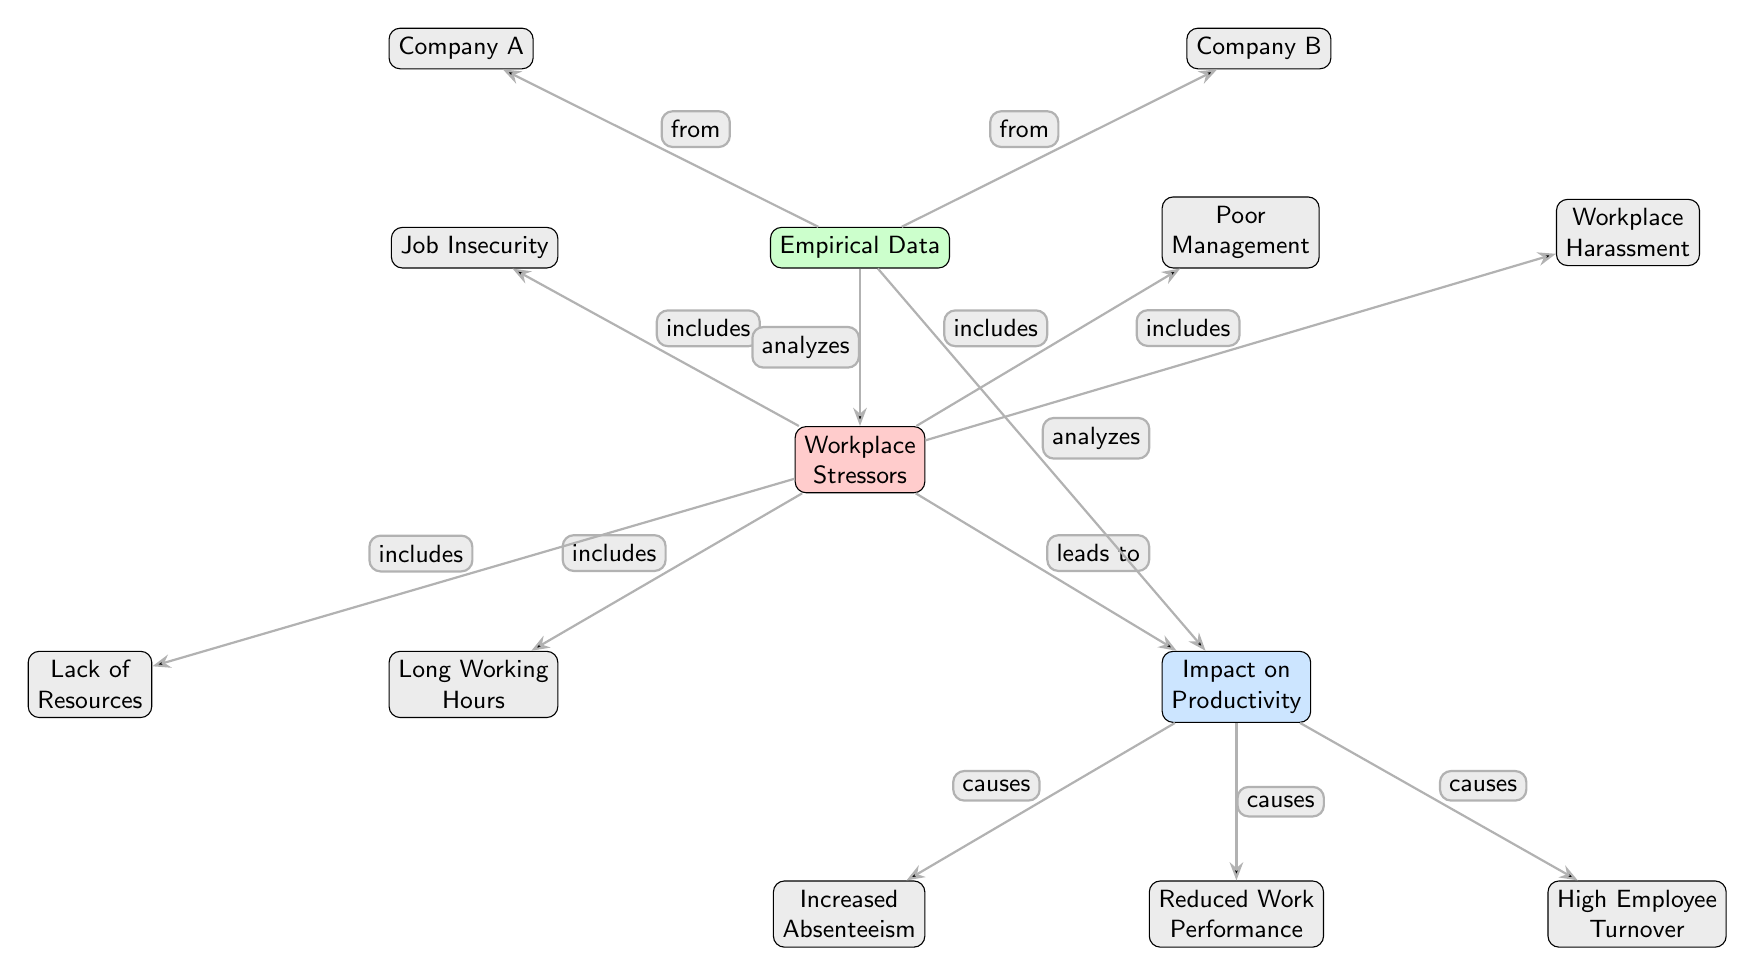What are the two nodes that are categorized under "Workplace Stressors"? The diagram indicates five stressors, but the specific question asks for two. Looking under the "Workplace Stressors" node, I see "Long Working Hours" and "Lack of Resources" are present.
Answer: Long Working Hours, Lack of Resources How many nodes are there in the diagram? To find the total number of nodes, I count each individual node in the diagram, including those under "Workplace Stressors," "Impact on Productivity," and "Empirical Data." I count 10 distinct nodes in total.
Answer: 10 Which impact is caused by the "Impact on Productivity" node? The diagram outlines three impacts stemming from "Impact on Productivity": "Increased Absenteeism," "Reduced Work Performance," and "High Employee Turnover." To answer, I just need any one of these impacts but will focus on "Increased Absenteeism" since it is the first listed impact.
Answer: Increased Absenteeism What is the central node of the diagram labeled as? The central node represents the main category of factors affecting outcomes in the diagram. It is labeled "Workplace Stressors." Therefore, the answer is the label of this node.
Answer: Workplace Stressors Which company data nodes analyze the "Impact on Productivity"? The diagram specifies that the "Empirical Data" node analyzes both the "Workplace Stressors" and "Impact on Productivity" nodes. Among the sources of this empirical data are "Company A" and "Company B." Thus, either company can be an answer, but I'll provide "Company A" as it is first in the order.
Answer: Company A What relationships connect "Poor Management" to the main outcome? The relationship between "Poor Management," which sits under "Workplace Stressors," and the main outcome can be traced through the "Workplace Stressors" node leading to the "Impact on Productivity" node. This connects it indirectly. The specific relationship is "includes," and then "leads to."
Answer: includes, leads to What is the position of the node labeled "Job Insecurity"? To find the position of "Job Insecurity," I look at the layout of the diagram. It is positioned above and to the left of the main node labeled "Workplace Stressors."
Answer: Above left of Workplace Stressors How many impacts are listed under "Impact on Productivity"? By reviewing the impacts listed under the "Impact on Productivity" node, I can identify three distinct impacts: "Increased Absenteeism," "Reduced Work Performance," and "High Employee Turnover." Hence, the number of impacts is three.
Answer: 3 